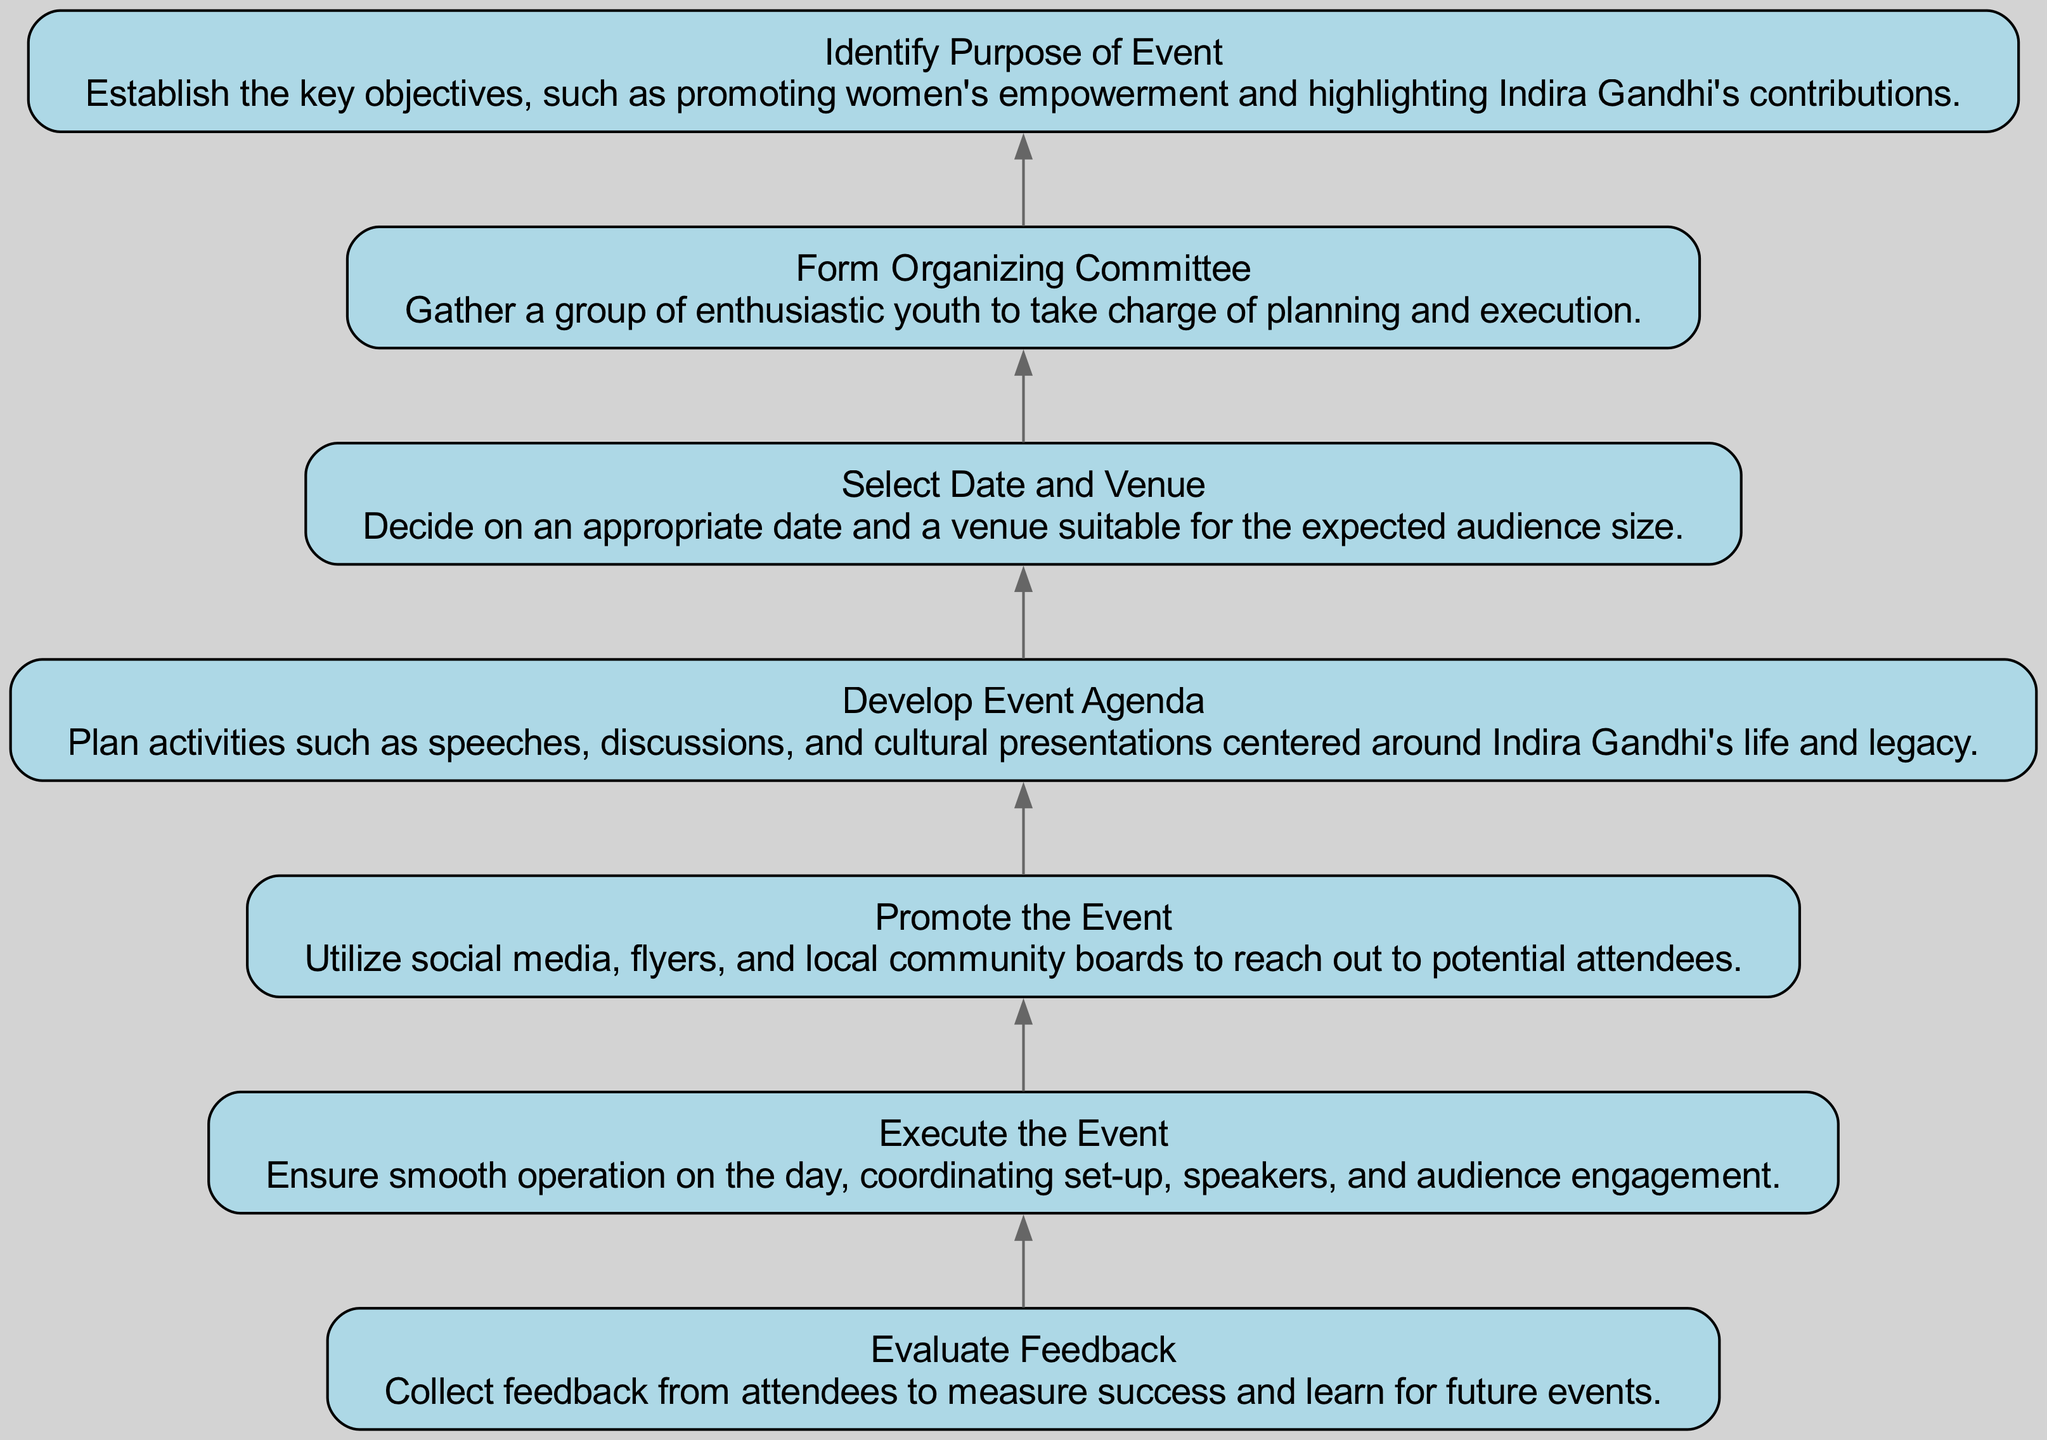What is the first step in organizing the event? The first step is "Identify Purpose of Event," which establishes the key objectives like promoting women's empowerment and highlighting Indira Gandhi's contributions.
Answer: Identify Purpose of Event How many total steps are in the flow chart? There are seven elements identified in the flow chart, each representing a different step in organizing the event.
Answer: 7 What step comes immediately after "Select Date and Venue"? The step that comes immediately after "Select Date and Venue" is "Develop Event Agenda." This relationship is established by the directed connection in the flow chart.
Answer: Develop Event Agenda Which step involves collecting feedback? The step that involves collecting feedback is "Evaluate Feedback," which is positioned at the top of the chart and is the final action in the process.
Answer: Evaluate Feedback What is the last step in the organization process? The last step in the organization process is "Evaluate Feedback," which helps measure success and informs future events based on attendees' input.
Answer: Evaluate Feedback How many promoting actions are mentioned in the flow chart? The flow chart mentions one action specifically related to promotion, which is "Promote the Event." This is a distinct step dedicated to outreach efforts.
Answer: 1 What does the "Execute the Event" step ensure? The "Execute the Event" step ensures smooth operation on the event day, coordinating set-up, speakers, and engaging the audience during the proceedings.
Answer: Smooth operation What is the relationship between "Develop Event Agenda" and "Execute the Event"? The relationship is sequential: "Develop Event Agenda" is the step that precedes "Execute the Event," indicating that the agenda must be prepared before the actual execution can occur.
Answer: Sequential relationship What type of feedback is collected during the last step? The feedback collected during the last step is from attendees, aimed at measuring the success of the event and gathering insights for future planning.
Answer: Attendee feedback 